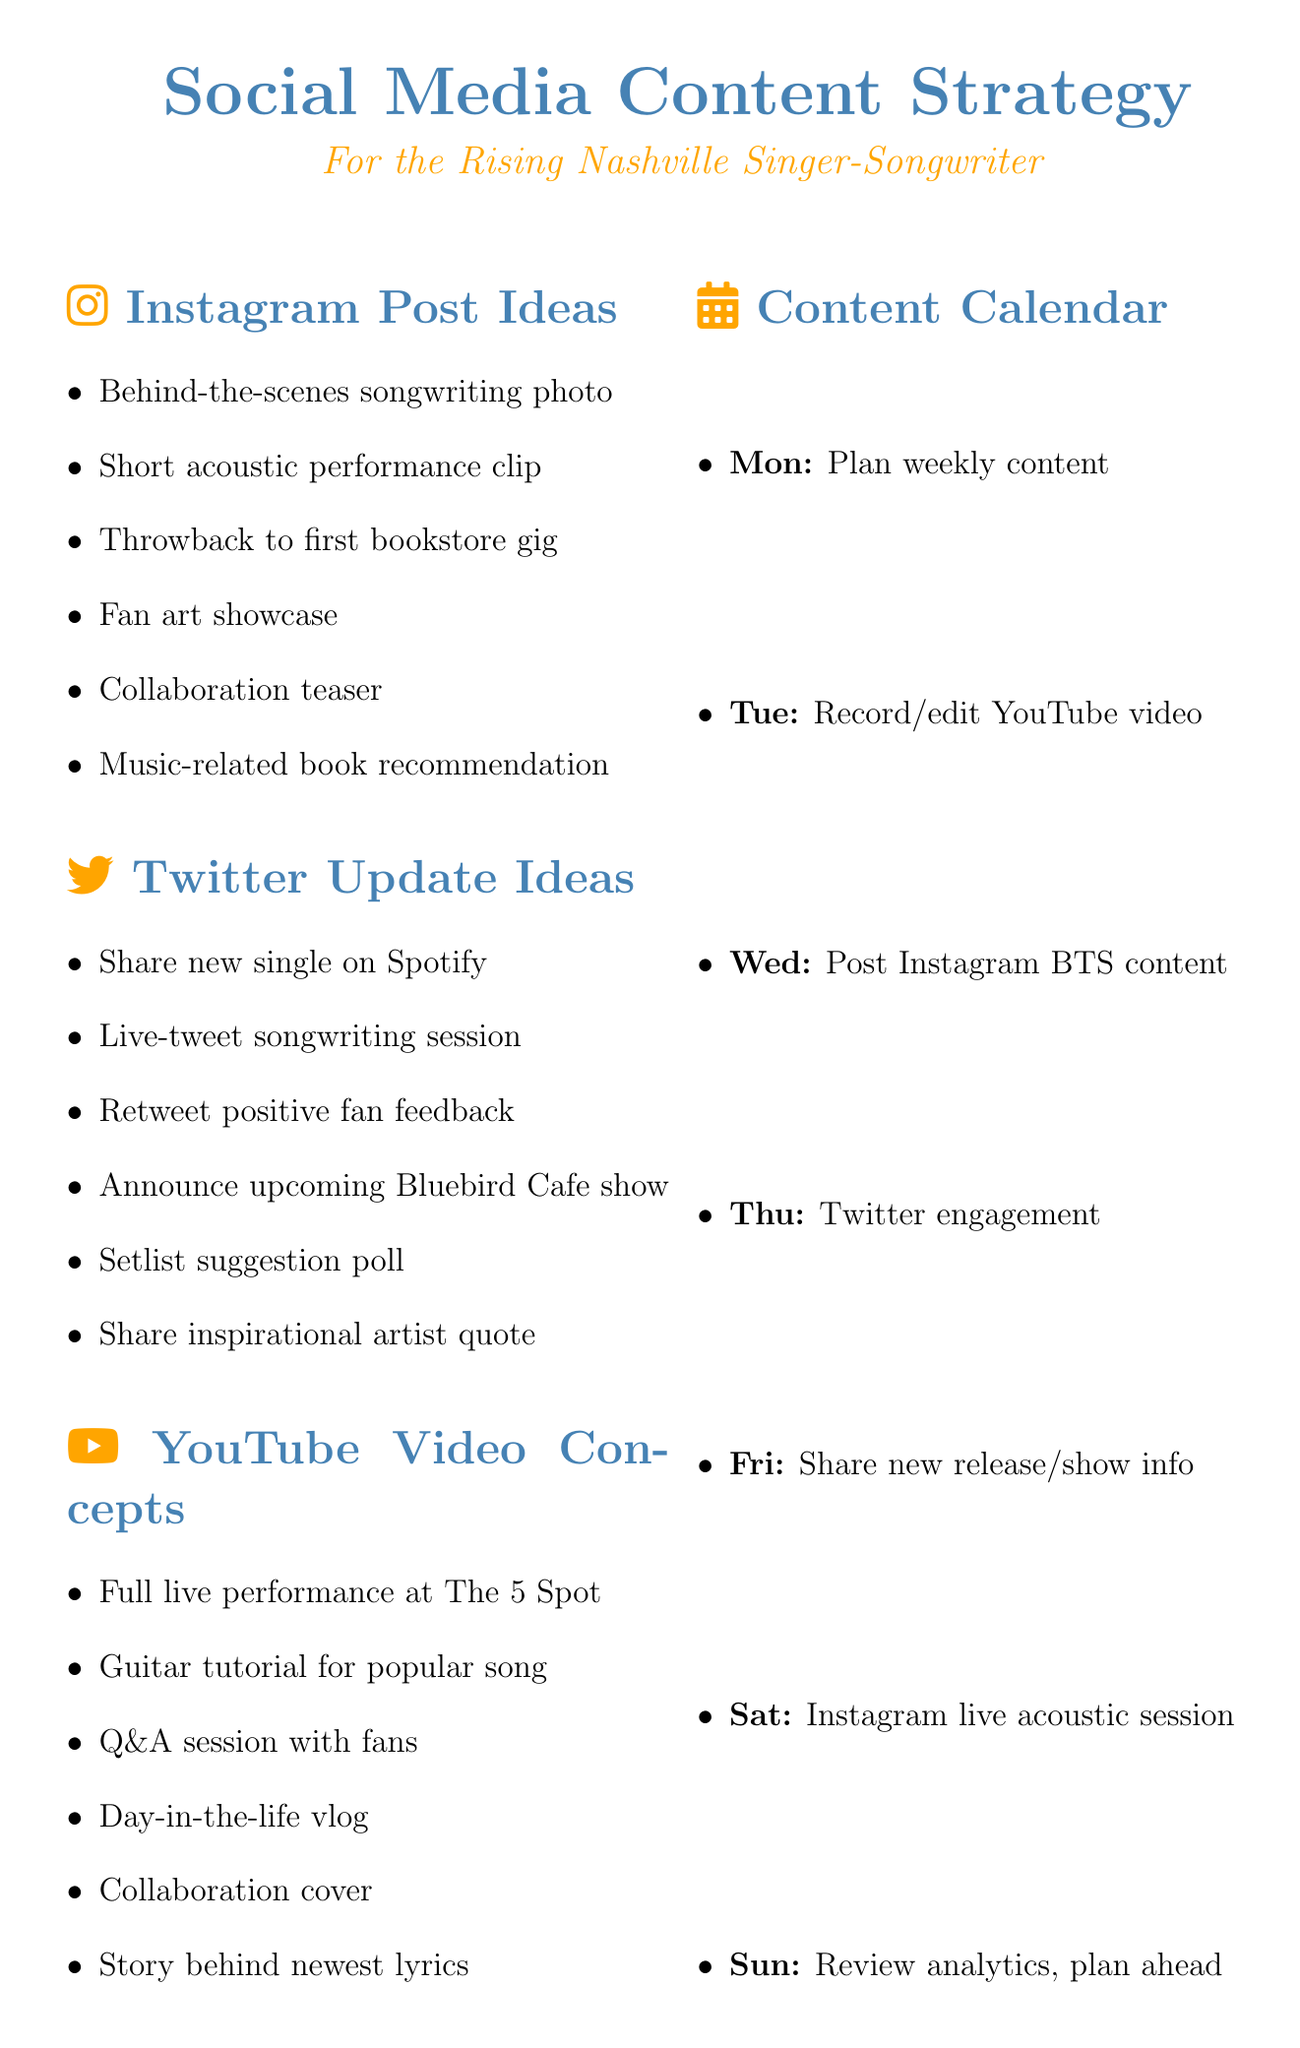What are two Instagram post ideas? The document lists several post ideas for Instagram, including "Behind-the-scenes photo of songwriting process" and "Short video clip of acoustic performance."
Answer: Behind-the-scenes photo of songwriting process, Short video clip of acoustic performance What day is scheduled for recording and editing a YouTube video? The content calendar specifies that recording and editing a YouTube video is scheduled for Tuesday.
Answer: Tuesday List one type of collaboration opportunity mentioned. The memo includes various collaboration opportunities such as reaching out to local music bloggers for features.
Answer: Local music bloggers What is one tip for content creation? The document suggests several tips for content creation, one of which is to maintain consistent branding across all platforms.
Answer: Maintain consistent branding What task is planned for Saturday? According to the content calendar, Saturday's task is to live stream an acoustic session on Instagram.
Answer: Live stream acoustic session on Instagram How many video concepts are listed for YouTube? The document contains a total of six video concepts for YouTube.
Answer: Six What should be shared on Twitter regarding performance announcements? The document indicates that one of the Twitter update ideas is to announce an upcoming performance at The Bluebird Cafe.
Answer: Announce upcoming performance at The Bluebird Cafe Which social media platform includes fan art showcase as an idea? The memo specifies that fan art showcase is among the post ideas for Instagram.
Answer: Instagram What is an example of an Instagram post idea related to collaboration? The document lists "Collaboration teaser with local musician" as an Instagram post idea related to collaboration.
Answer: Collaboration teaser with local musician 